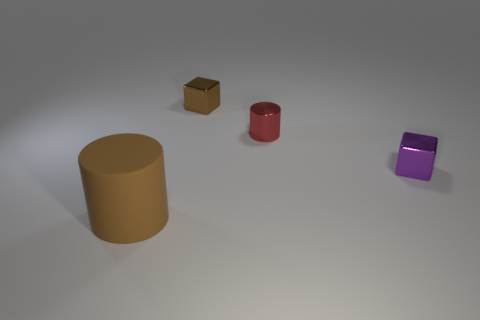Is the number of tiny purple things behind the red cylinder greater than the number of small red cylinders on the right side of the brown matte cylinder? Upon inspection of the image, there appears to be only one small purple cube positioned behind the red cylinder, and there is not any small red cylinder present on the right side of the large brown matte cylinder. Therefore, the answer is 'no', but to clarify, this is because there are zero red cylinders to compare to the single purple cube. 